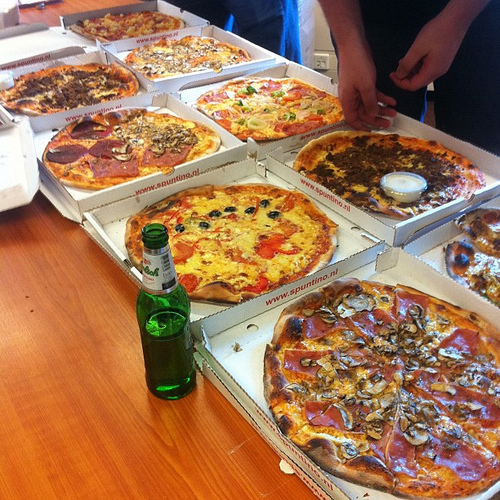Are there fruits in the box that the sausage is to the right of? No, there are no fruits in the box that the sausage is to the right of. 